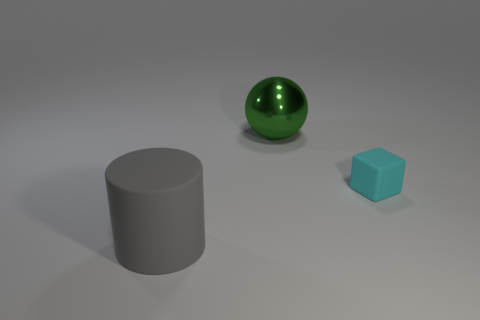Is the number of tiny metal cubes less than the number of cyan matte blocks?
Provide a short and direct response. Yes. There is a cube; does it have the same size as the gray matte cylinder in front of the big metal thing?
Keep it short and to the point. No. Are there any other things that are the same shape as the tiny object?
Ensure brevity in your answer.  No. The green shiny sphere is what size?
Provide a succinct answer. Large. Are there fewer large spheres that are left of the cyan matte block than tiny gray shiny balls?
Provide a short and direct response. No. Do the cyan rubber cube and the green shiny ball have the same size?
Ensure brevity in your answer.  No. Is there any other thing that is the same size as the green object?
Your answer should be compact. Yes. What color is the big cylinder that is made of the same material as the cyan thing?
Keep it short and to the point. Gray. Is the number of big metallic things that are to the left of the matte cube less than the number of big matte cylinders in front of the gray cylinder?
Keep it short and to the point. No. What number of small matte blocks are the same color as the sphere?
Your answer should be very brief. 0. 